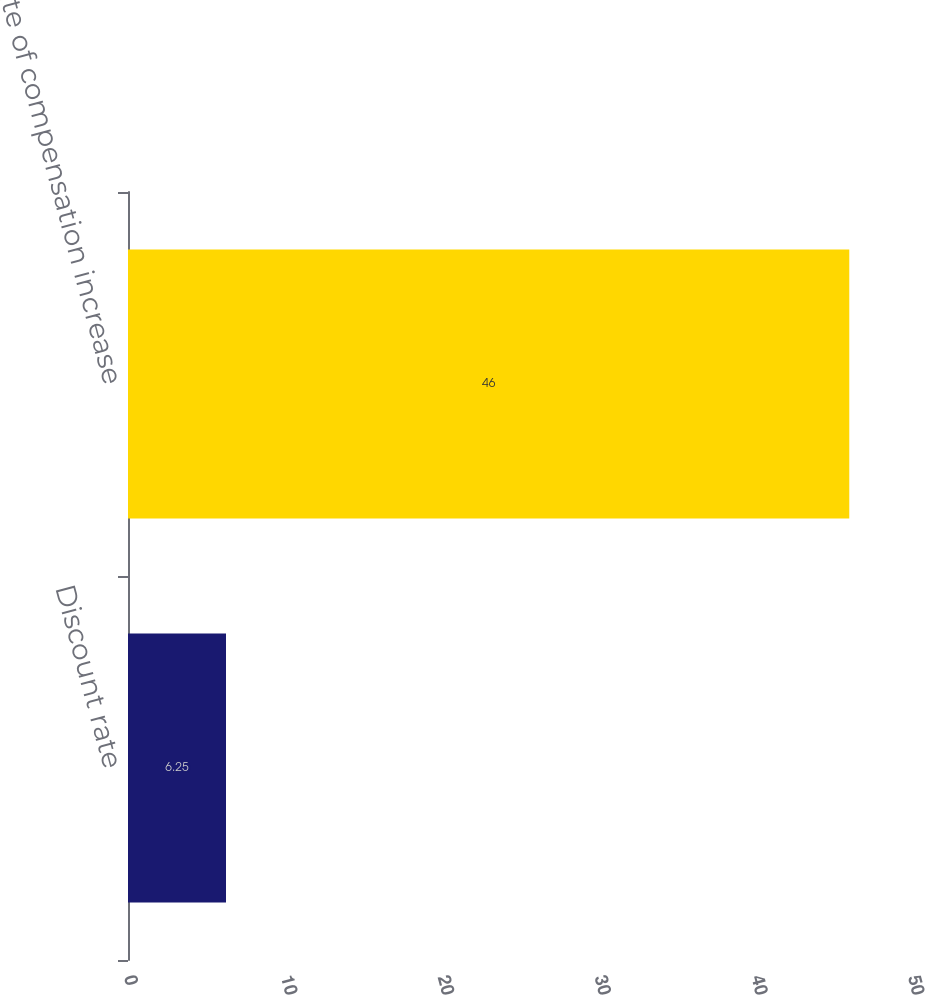<chart> <loc_0><loc_0><loc_500><loc_500><bar_chart><fcel>Discount rate<fcel>Rate of compensation increase<nl><fcel>6.25<fcel>46<nl></chart> 